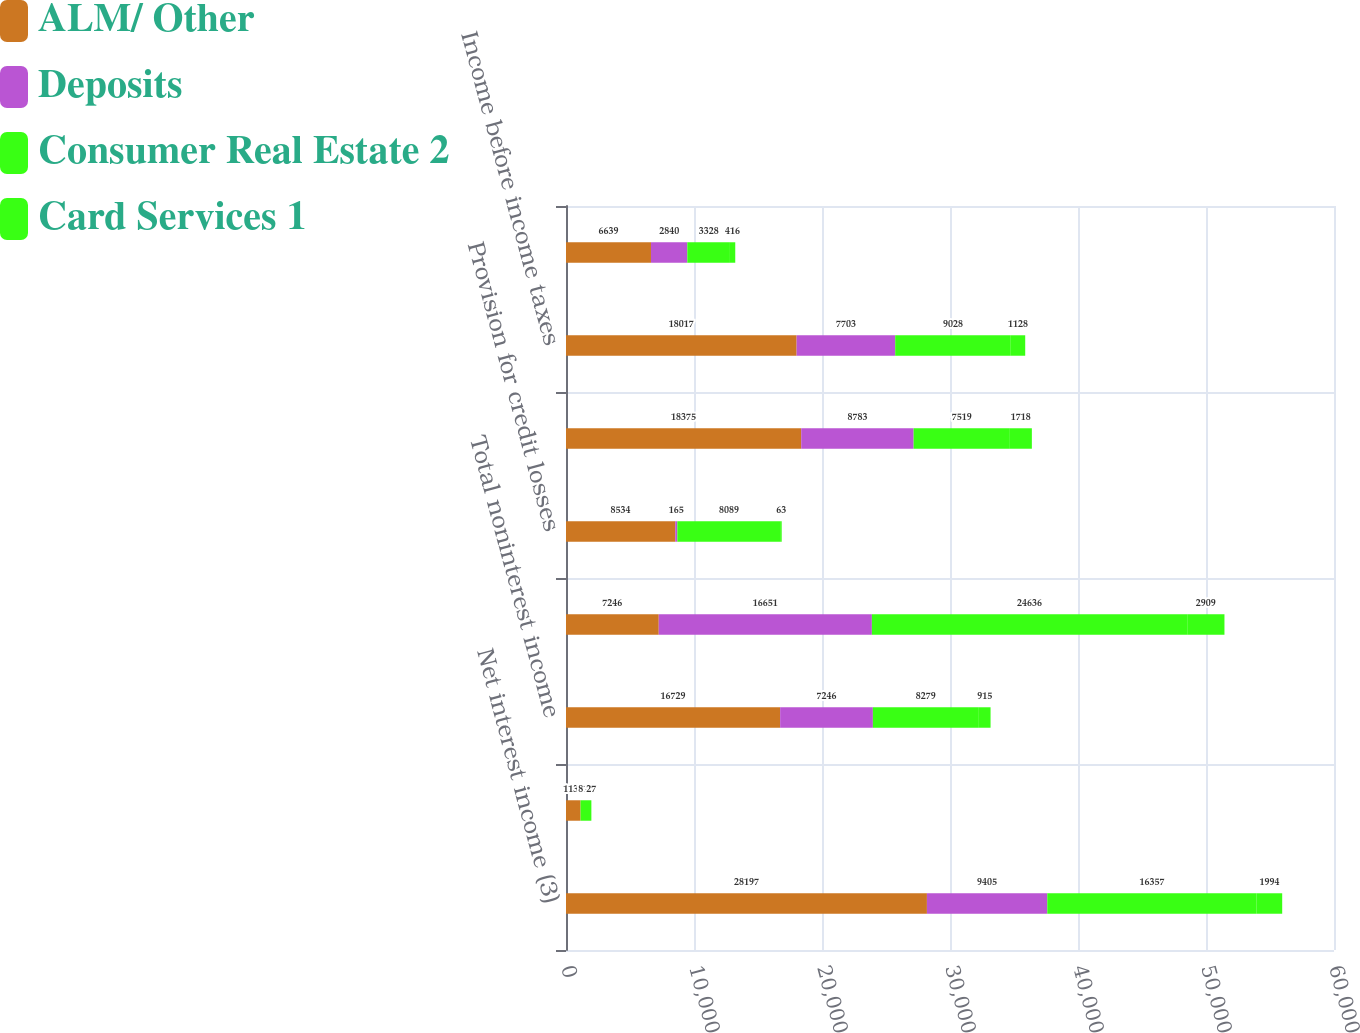Convert chart to OTSL. <chart><loc_0><loc_0><loc_500><loc_500><stacked_bar_chart><ecel><fcel>Net interest income (3)<fcel>All other income<fcel>Total noninterest income<fcel>Total revenue net of interest<fcel>Provision for credit losses<fcel>Noninterest expense<fcel>Income before income taxes<fcel>Income tax expense (3)<nl><fcel>ALM/ Other<fcel>28197<fcel>1136<fcel>16729<fcel>7246<fcel>8534<fcel>18375<fcel>18017<fcel>6639<nl><fcel>Deposits<fcel>9405<fcel>1<fcel>7246<fcel>16651<fcel>165<fcel>8783<fcel>7703<fcel>2840<nl><fcel>Consumer Real Estate 2<fcel>16357<fcel>819<fcel>8279<fcel>24636<fcel>8089<fcel>7519<fcel>9028<fcel>3328<nl><fcel>Card Services 1<fcel>1994<fcel>27<fcel>915<fcel>2909<fcel>63<fcel>1718<fcel>1128<fcel>416<nl></chart> 